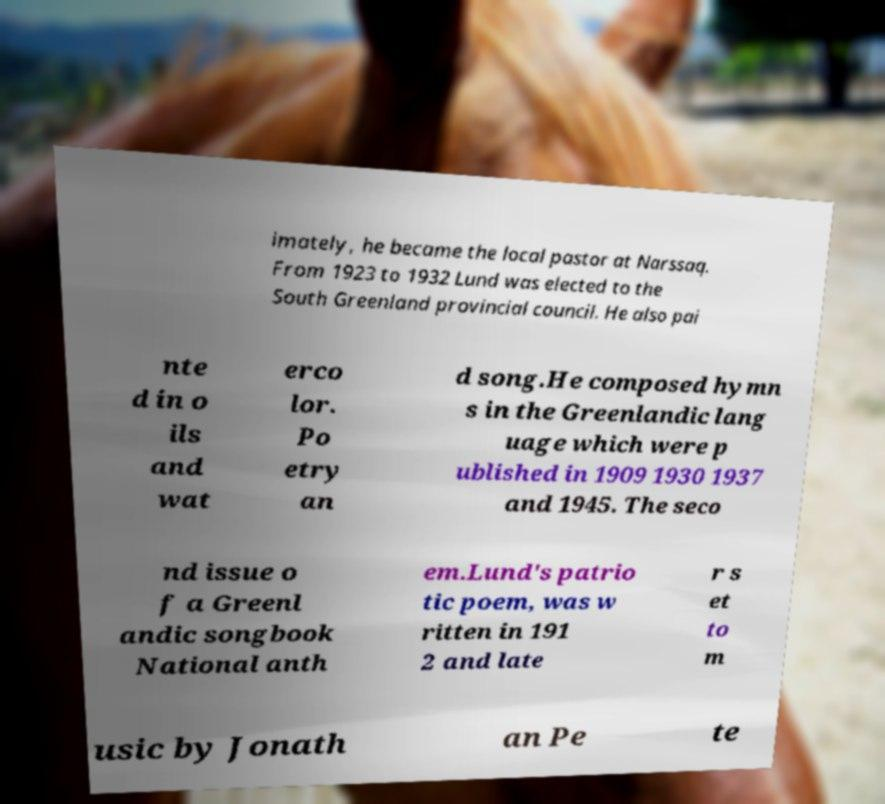What messages or text are displayed in this image? I need them in a readable, typed format. imately, he became the local pastor at Narssaq. From 1923 to 1932 Lund was elected to the South Greenland provincial council. He also pai nte d in o ils and wat erco lor. Po etry an d song.He composed hymn s in the Greenlandic lang uage which were p ublished in 1909 1930 1937 and 1945. The seco nd issue o f a Greenl andic songbook National anth em.Lund's patrio tic poem, was w ritten in 191 2 and late r s et to m usic by Jonath an Pe te 